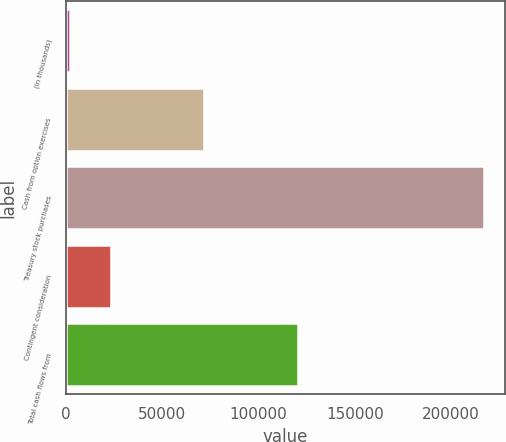Convert chart. <chart><loc_0><loc_0><loc_500><loc_500><bar_chart><fcel>(In thousands)<fcel>Cash from option exercises<fcel>Treasury stock purchases<fcel>Contingent consideration<fcel>Total cash flows from<nl><fcel>2014<fcel>71411<fcel>217082<fcel>23520.8<fcel>120324<nl></chart> 